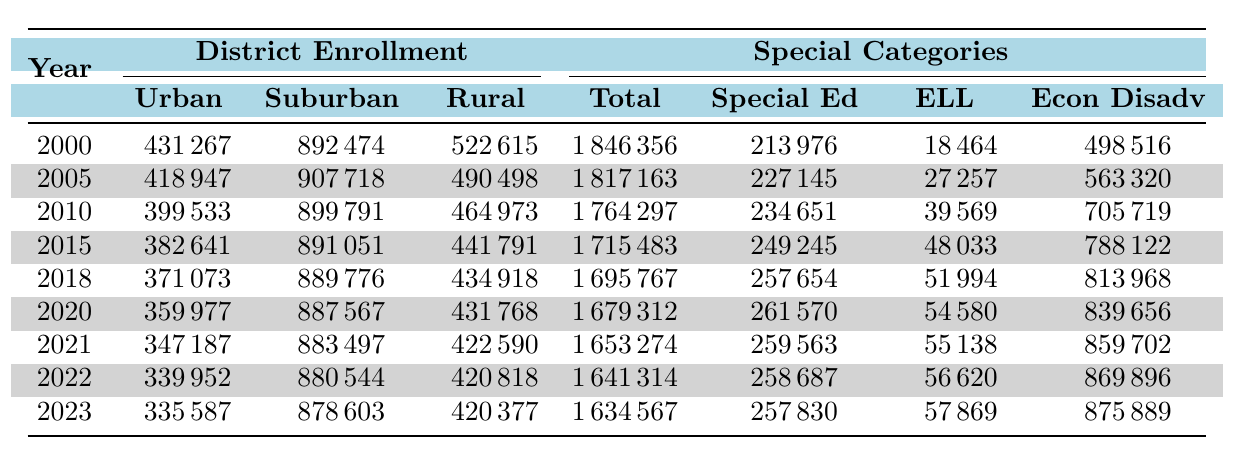What was the total enrollment in Ohio public schools in 2010? The table indicates that the total enrollment for the year 2010 was recorded as 1,764,297.
Answer: 1,764,297 What year had the highest enrollment of English Language Learners? By examining the table, the year 2022 shows the highest enrollment of English Language Learners at 56,620.
Answer: 2022 How much did rural district enrollment decrease from 2000 to 2023? The rural district enrollment in 2000 was 522,615, and in 2023 it was 420,377. The decrease is calculated as 522,615 - 420,377 = 102,238.
Answer: 102,238 What is the average yearly enrollment for economically disadvantaged students from 2000 to 2023? To find the average, first sum the enrollments: 498,516 + 563,320 + 705,719 + 788,122 + 813,968 + 839,656 + 859,702 + 869,896 + 875,889 = 6,491,844. There are 9 years, so the average is 6,491,844 / 9 = 721,316.
Answer: 721,316 Did special education enrollment ever exceed 250,000 during this period? By checking the values, the highest special education enrollment recorded was 261,570 in 2020, exceeding 250,000.
Answer: Yes What was the total enrollment in 2021 compared to 2005? The total enrollment in 2021 was 1,653,274 and in 2005 it was 1,817,163. The difference is calculated as 1,817,163 - 1,653,274 = 163,889.
Answer: 163,889 In which year did urban district enrollment drop below 350,000? Urban district enrollment did not drop below 350,000 in any of the given years; the lowest recorded was 347,187 in 2021.
Answer: 2021 What percentage of total enrollment in 2023 was composed of economically disadvantaged students? The total enrollment in 2023 is 1,634,567 and economically disadvantaged enrollment is 875,889. The percentage is calculated as (875,889 / 1,634,567) * 100 = 53.6%.
Answer: 53.6% How does the Special Education Enrollment in 2022 compare to that in 2010? Special education enrollment in 2022 was 258,687, while in 2010 it was 234,651. The increase is calculated as 258,687 - 234,651 = 24,036.
Answer: 24,036 Identify the year with the lowest total enrollment and its corresponding figure. The lowest total enrollment recorded was in 2023, with a figure of 1,634,567.
Answer: 1,634,567 